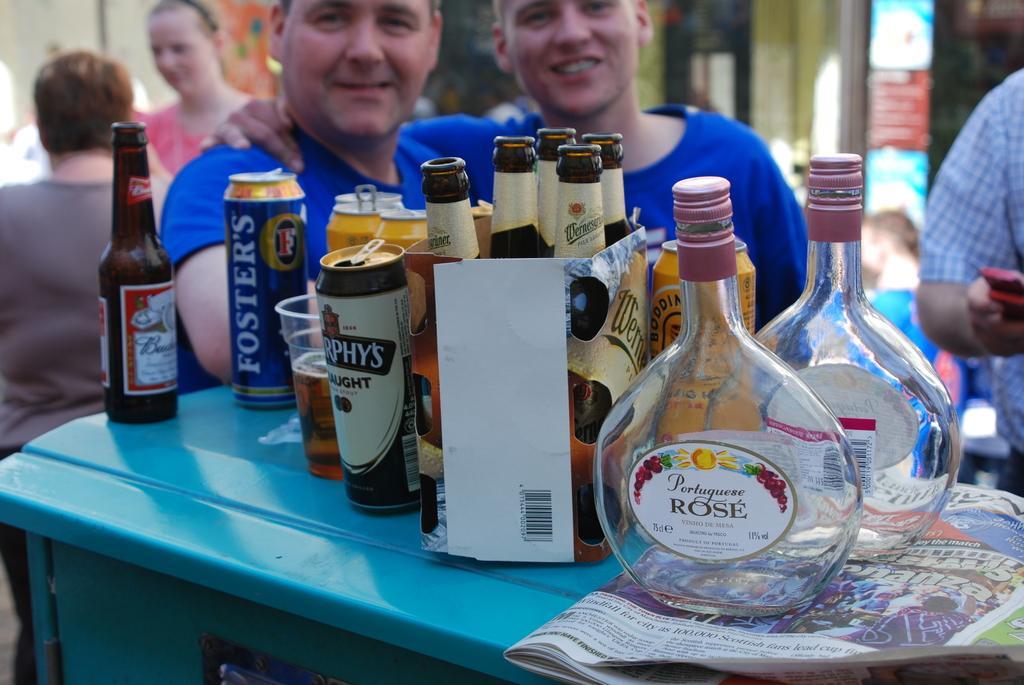Could you give a brief overview of what you see in this image? there are bottles, tins and glasses placed on a blue table. at the right there is a newspaper on which there are 2 transparent glass bottles on which portuguese rose is written. behind them there are 2 people wearing blue shirt standing. at the right there is a person standing. at the left there are 2 people. 